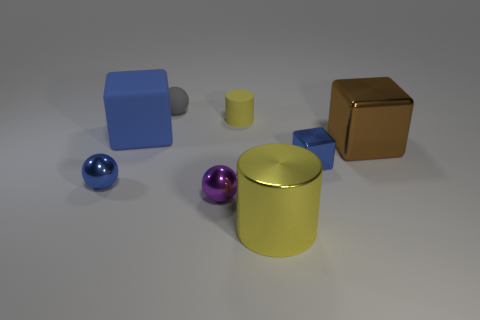Subtract all yellow cylinders. How many were subtracted if there are1yellow cylinders left? 1 Add 2 yellow shiny cylinders. How many objects exist? 10 Subtract all spheres. How many objects are left? 5 Add 1 big blue metal balls. How many big blue metal balls exist? 1 Subtract 0 green spheres. How many objects are left? 8 Subtract all metallic things. Subtract all yellow rubber things. How many objects are left? 2 Add 3 small yellow matte things. How many small yellow matte things are left? 4 